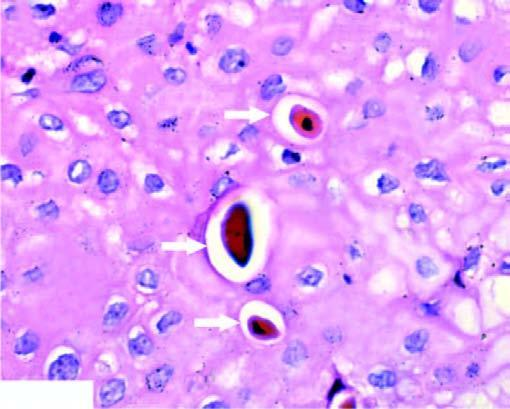has the surrounding zone clumped chromatin?
Answer the question using a single word or phrase. No 